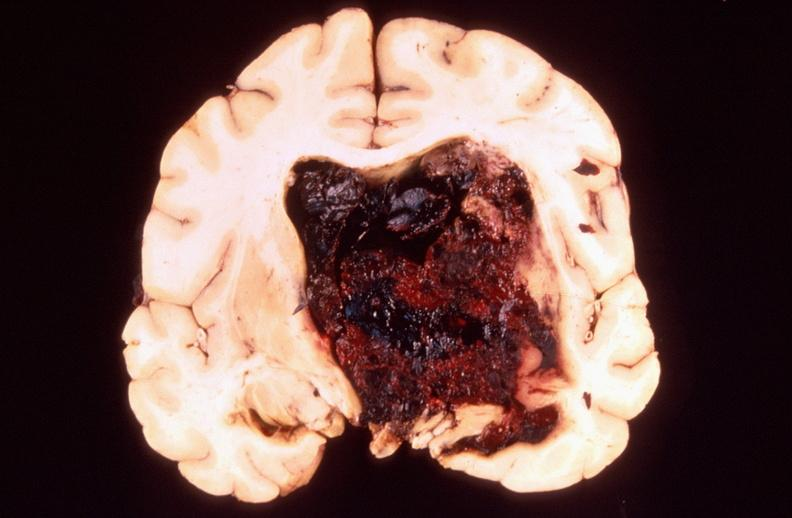does fibrous meningioma show brain, intracerebral hemorrhage?
Answer the question using a single word or phrase. No 